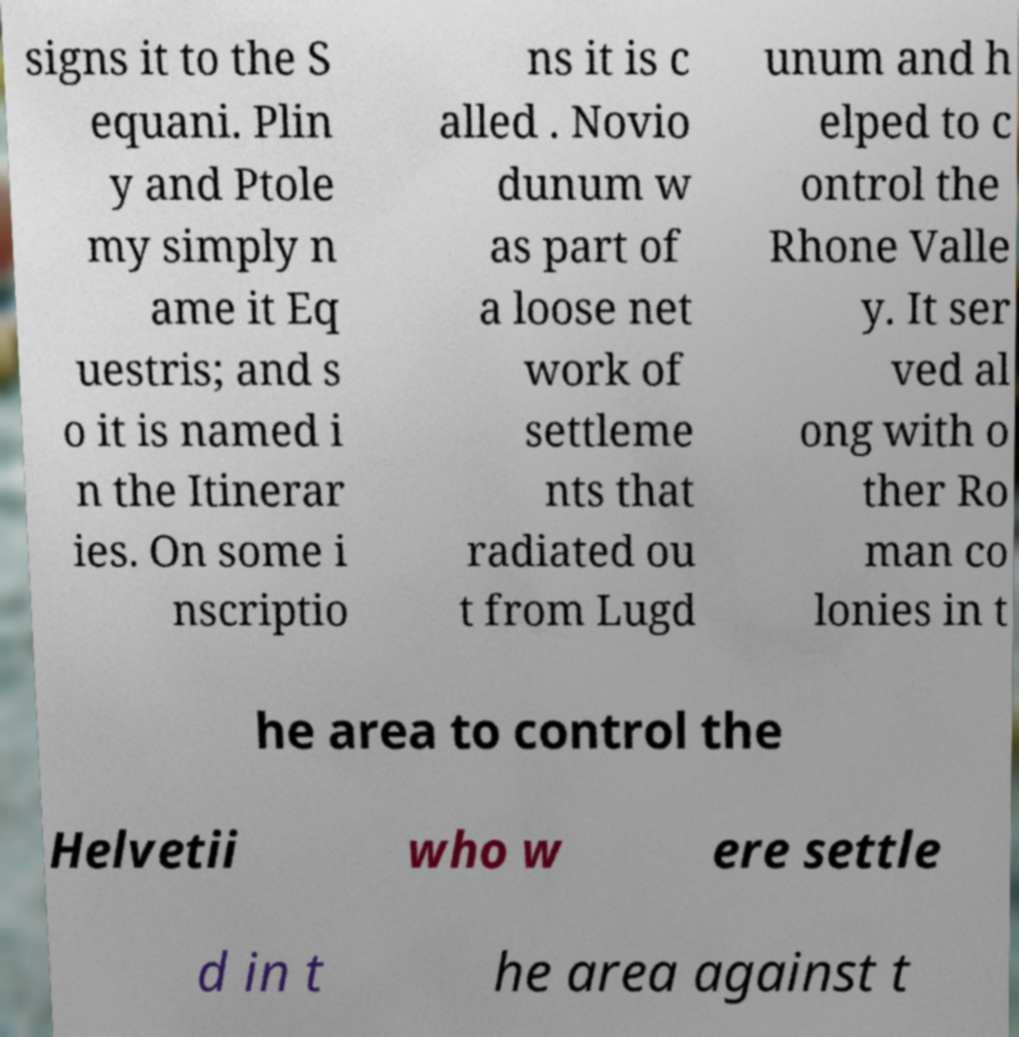Could you assist in decoding the text presented in this image and type it out clearly? signs it to the S equani. Plin y and Ptole my simply n ame it Eq uestris; and s o it is named i n the Itinerar ies. On some i nscriptio ns it is c alled . Novio dunum w as part of a loose net work of settleme nts that radiated ou t from Lugd unum and h elped to c ontrol the Rhone Valle y. It ser ved al ong with o ther Ro man co lonies in t he area to control the Helvetii who w ere settle d in t he area against t 